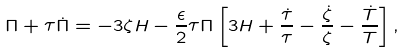<formula> <loc_0><loc_0><loc_500><loc_500>\Pi + \tau \dot { \Pi } = - 3 \zeta H - \frac { \epsilon } { 2 } \tau \Pi \left [ 3 H + \frac { \dot { \tau } } { \tau } - \frac { \dot { \zeta } } { \zeta } - \frac { \dot { T } } { T } \right ] ,</formula> 